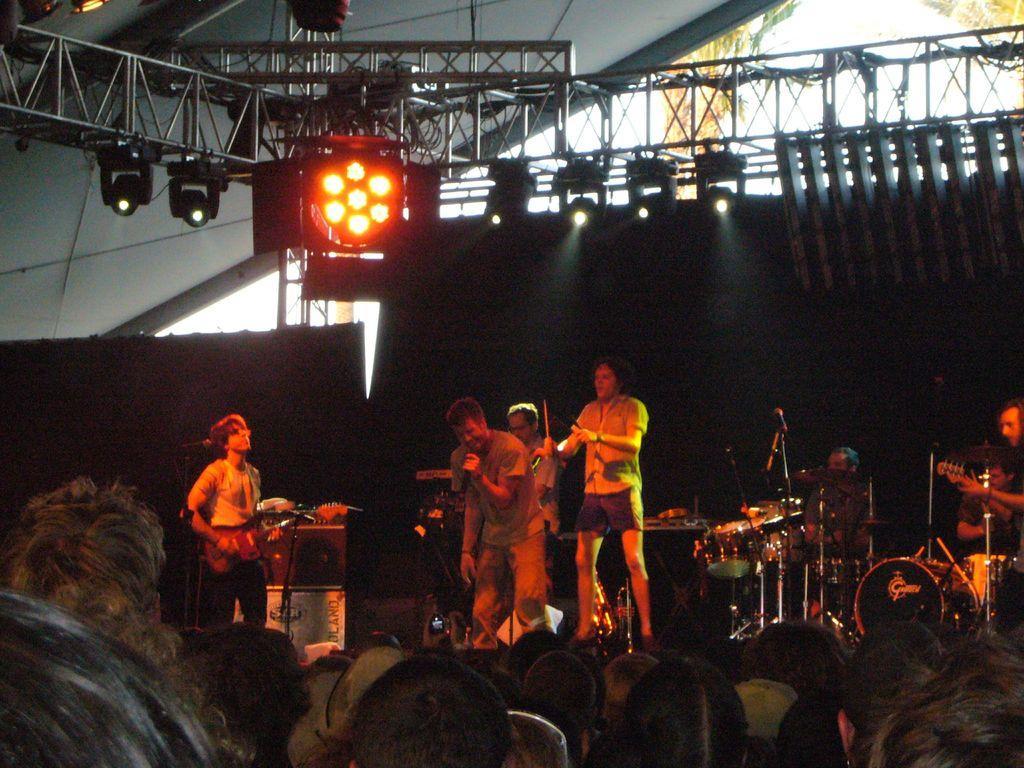In one or two sentences, can you explain what this image depicts? there are so many people standing on the stage playing a music and one month singing in a microphone behind them there are other people watching the show. 